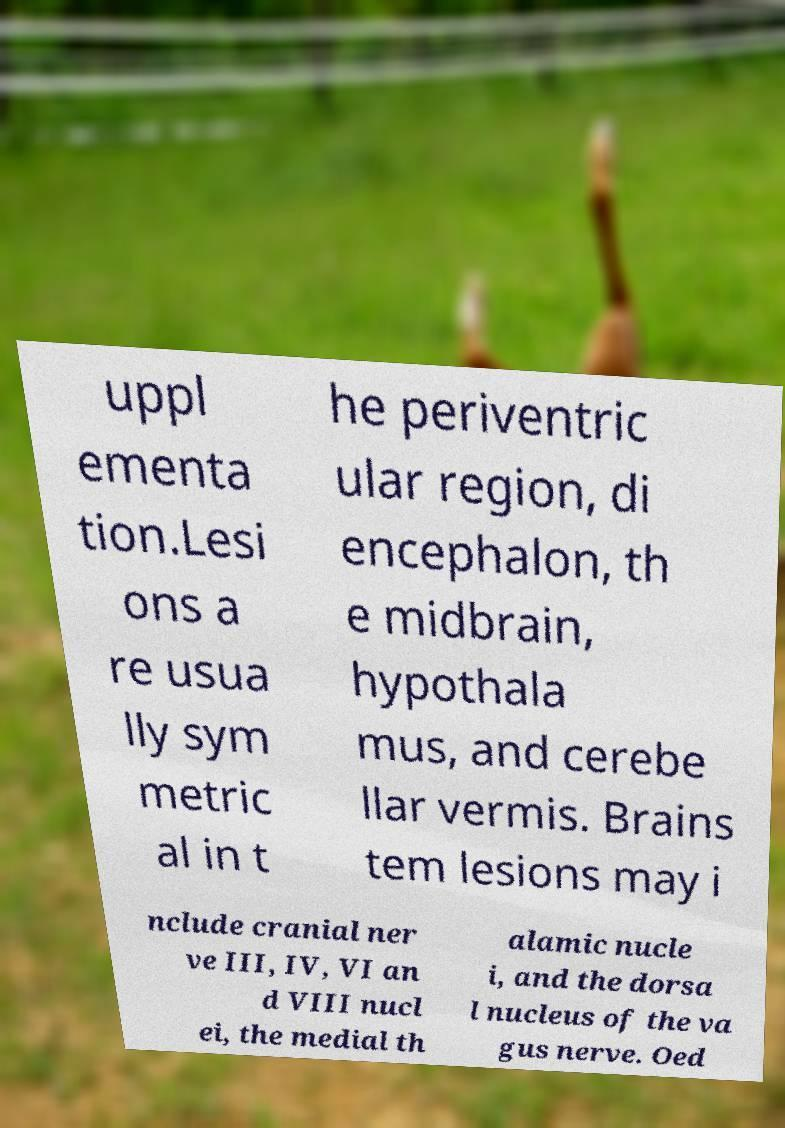Can you accurately transcribe the text from the provided image for me? uppl ementa tion.Lesi ons a re usua lly sym metric al in t he periventric ular region, di encephalon, th e midbrain, hypothala mus, and cerebe llar vermis. Brains tem lesions may i nclude cranial ner ve III, IV, VI an d VIII nucl ei, the medial th alamic nucle i, and the dorsa l nucleus of the va gus nerve. Oed 